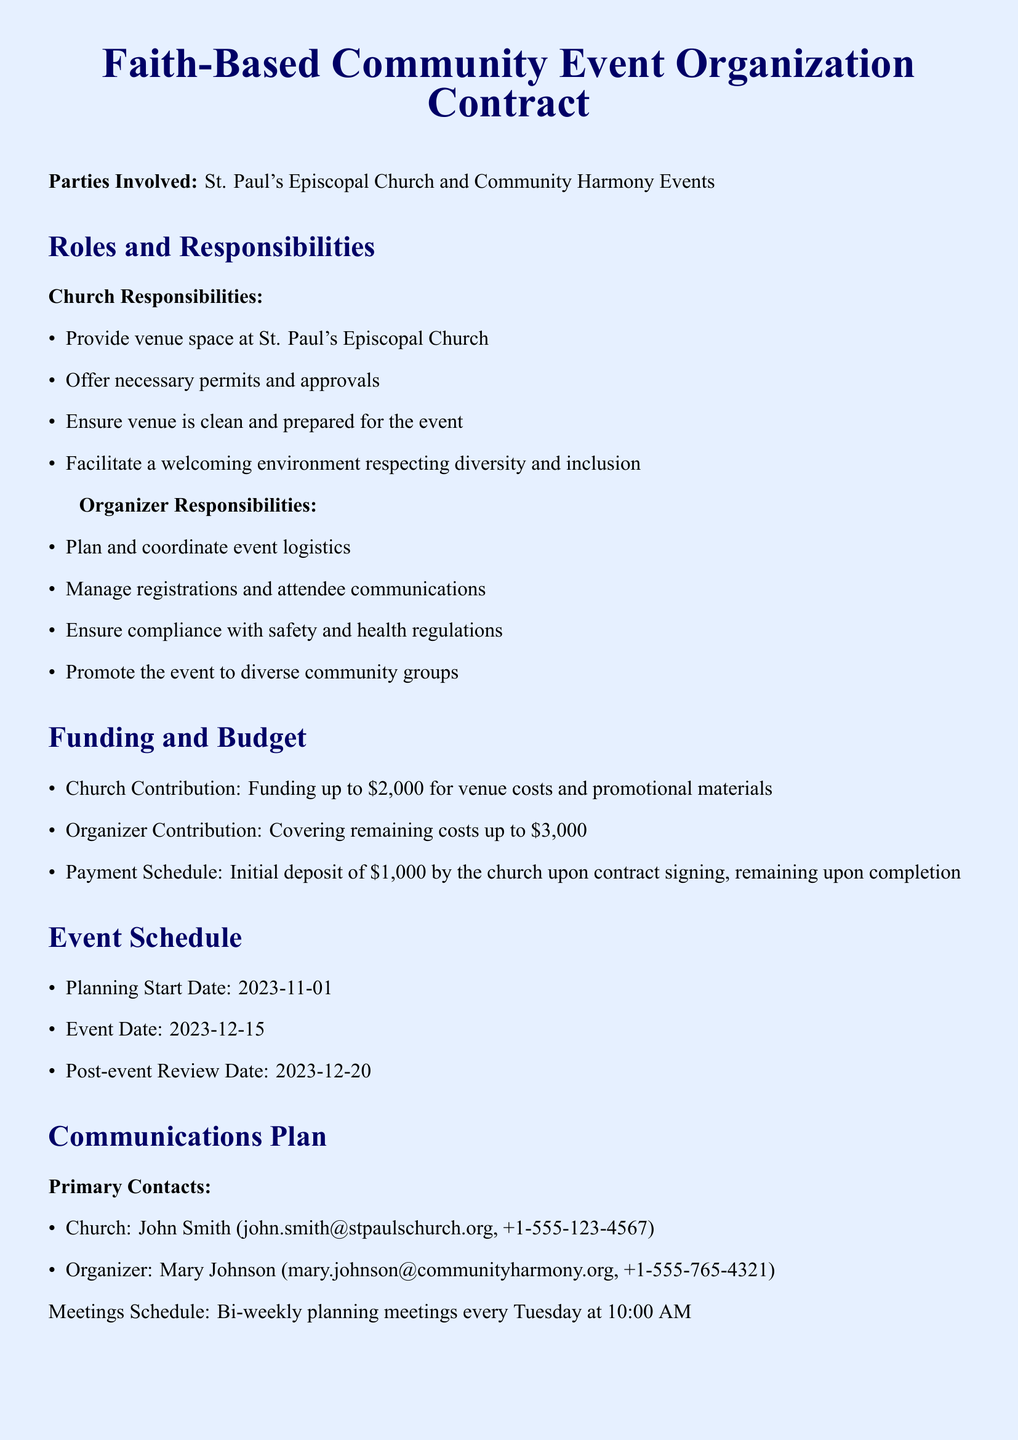What is the name of the church involved? The church involved is named St. Paul's Episcopal Church.
Answer: St. Paul's Episcopal Church What is the total funding contribution from the church? The church is contributing up to $2000 for the venue costs and promotional materials.
Answer: $2000 Who is the main contact for the church? The primary contact for the church is John Smith, whose email is provided in the document.
Answer: John Smith When is the event scheduled to take place? The event date is specified as December 15, 2023.
Answer: December 15, 2023 What is the contribution amount covered by the organizer? The organizer is responsible for covering remaining costs up to $3000.
Answer: $3000 What measures are included to promote diversity? Diversity measures include multilingual materials and translation services as well as accessibility for attendees.
Answer: Multilingual materials and translation services What date is the post-event review scheduled? The post-event review date is set for December 20, 2023.
Answer: December 20, 2023 Who is responsible for managing registrations and communications? The organizer is responsible for managing registrations and attendee communications.
Answer: Organizer What are the meeting times for planning meetings? Planning meetings are scheduled bi-weekly every Tuesday at 10:00 AM.
Answer: Every Tuesday at 10:00 AM 